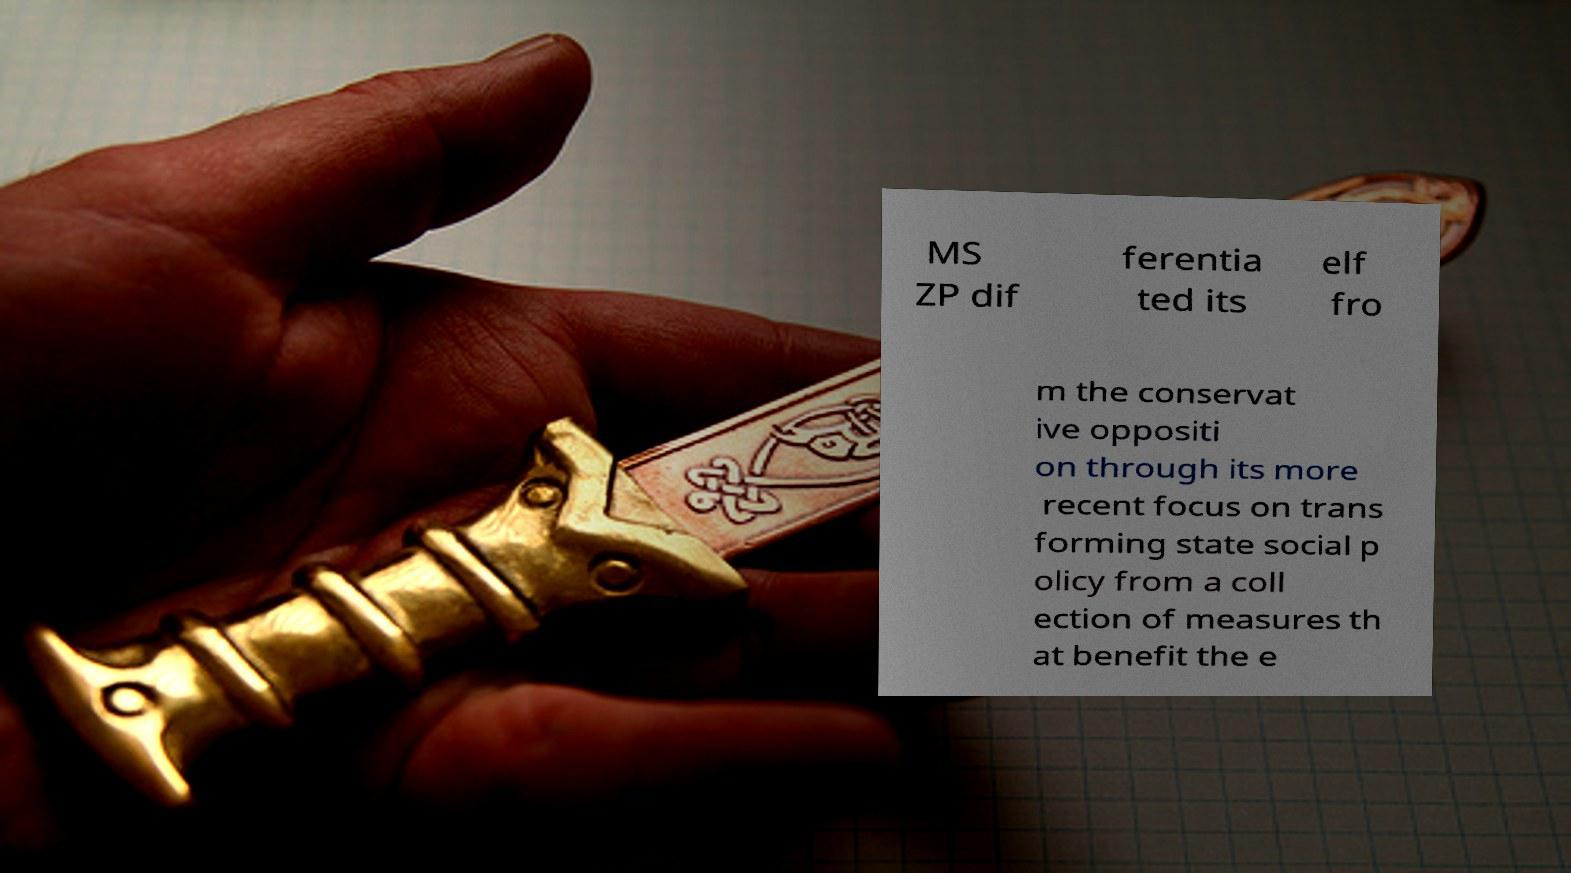Could you extract and type out the text from this image? MS ZP dif ferentia ted its elf fro m the conservat ive oppositi on through its more recent focus on trans forming state social p olicy from a coll ection of measures th at benefit the e 